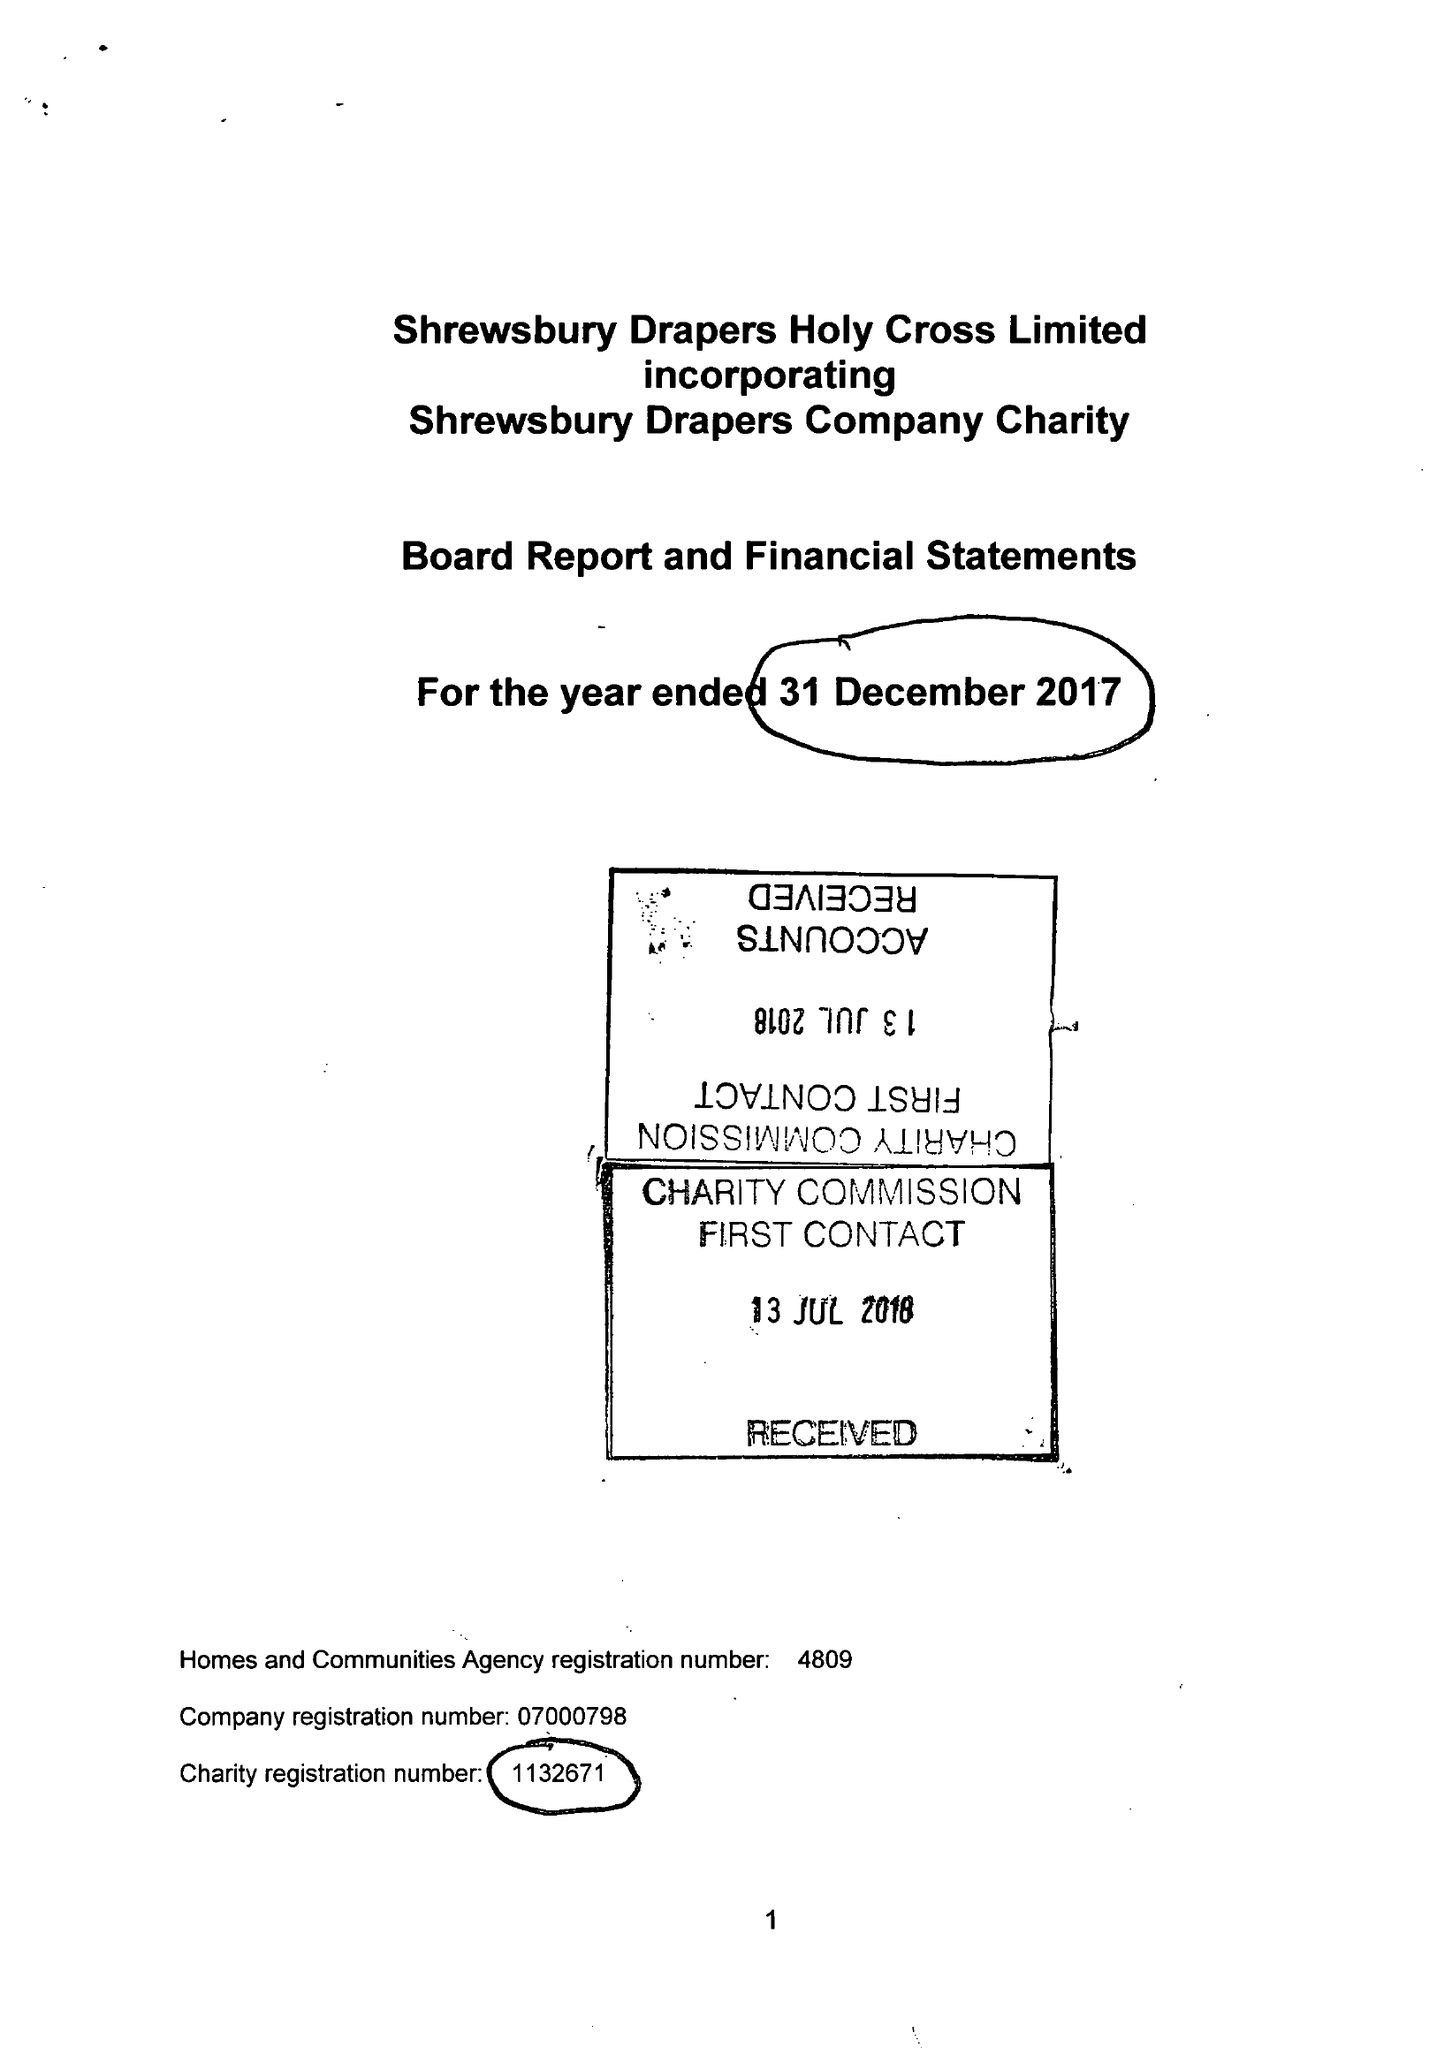What is the value for the address__postcode?
Answer the question using a single word or phrase. SY2 6BP 